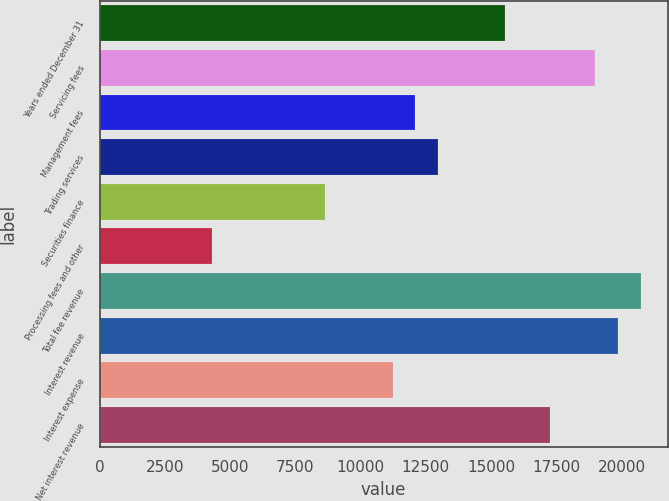Convert chart. <chart><loc_0><loc_0><loc_500><loc_500><bar_chart><fcel>Years ended December 31<fcel>Servicing fees<fcel>Management fees<fcel>Trading services<fcel>Securities finance<fcel>Processing fees and other<fcel>Total fee revenue<fcel>Interest revenue<fcel>Interest expense<fcel>Net interest revenue<nl><fcel>15549.2<fcel>19003.8<fcel>12094.6<fcel>12958.2<fcel>8639.96<fcel>4321.71<fcel>20731.1<fcel>19867.4<fcel>11230.9<fcel>17276.5<nl></chart> 